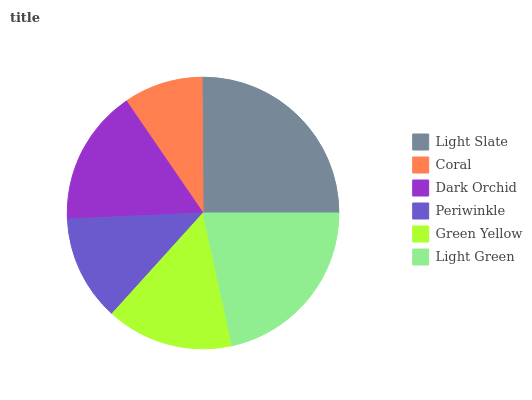Is Coral the minimum?
Answer yes or no. Yes. Is Light Slate the maximum?
Answer yes or no. Yes. Is Dark Orchid the minimum?
Answer yes or no. No. Is Dark Orchid the maximum?
Answer yes or no. No. Is Dark Orchid greater than Coral?
Answer yes or no. Yes. Is Coral less than Dark Orchid?
Answer yes or no. Yes. Is Coral greater than Dark Orchid?
Answer yes or no. No. Is Dark Orchid less than Coral?
Answer yes or no. No. Is Dark Orchid the high median?
Answer yes or no. Yes. Is Green Yellow the low median?
Answer yes or no. Yes. Is Light Green the high median?
Answer yes or no. No. Is Periwinkle the low median?
Answer yes or no. No. 